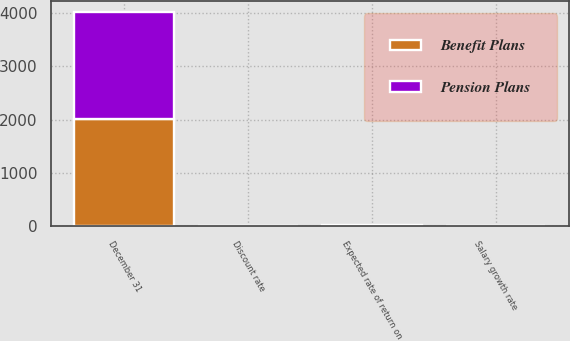Convert chart. <chart><loc_0><loc_0><loc_500><loc_500><stacked_bar_chart><ecel><fcel>December 31<fcel>Discount rate<fcel>Expected rate of return on<fcel>Salary growth rate<nl><fcel>Pension Plans<fcel>2010<fcel>5.5<fcel>7.6<fcel>4.15<nl><fcel>Benefit Plans<fcel>2010<fcel>5.9<fcel>8.7<fcel>4.5<nl></chart> 